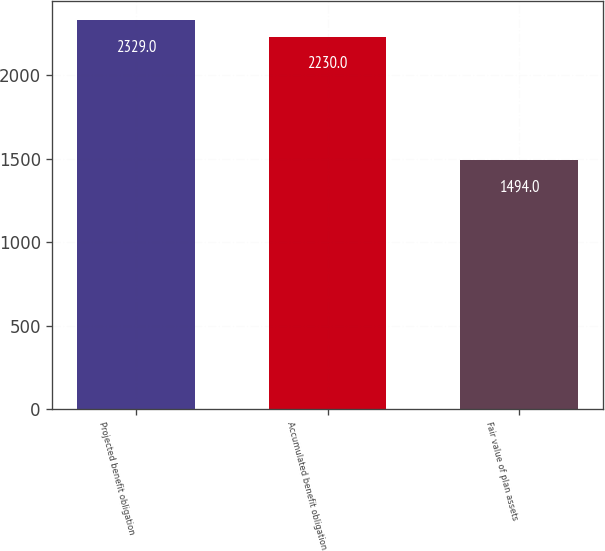<chart> <loc_0><loc_0><loc_500><loc_500><bar_chart><fcel>Projected benefit obligation<fcel>Accumulated benefit obligation<fcel>Fair value of plan assets<nl><fcel>2329<fcel>2230<fcel>1494<nl></chart> 